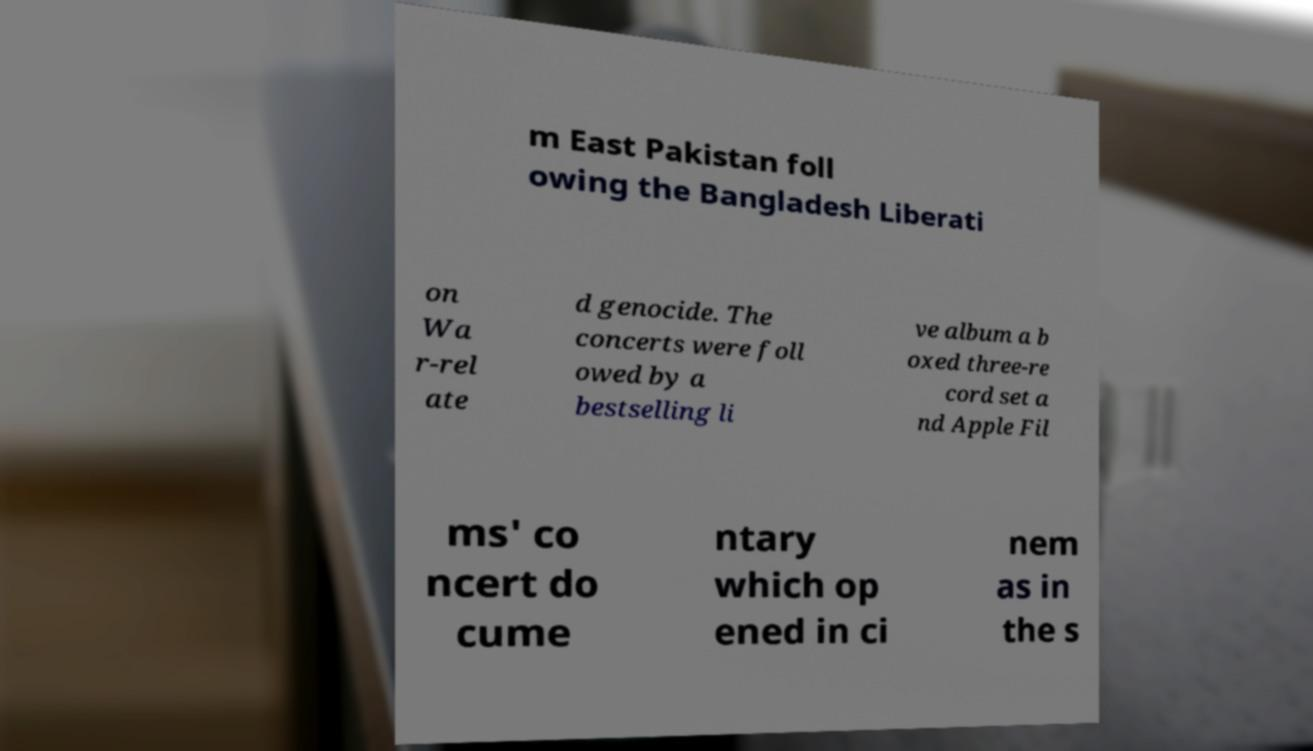Can you read and provide the text displayed in the image?This photo seems to have some interesting text. Can you extract and type it out for me? m East Pakistan foll owing the Bangladesh Liberati on Wa r-rel ate d genocide. The concerts were foll owed by a bestselling li ve album a b oxed three-re cord set a nd Apple Fil ms' co ncert do cume ntary which op ened in ci nem as in the s 